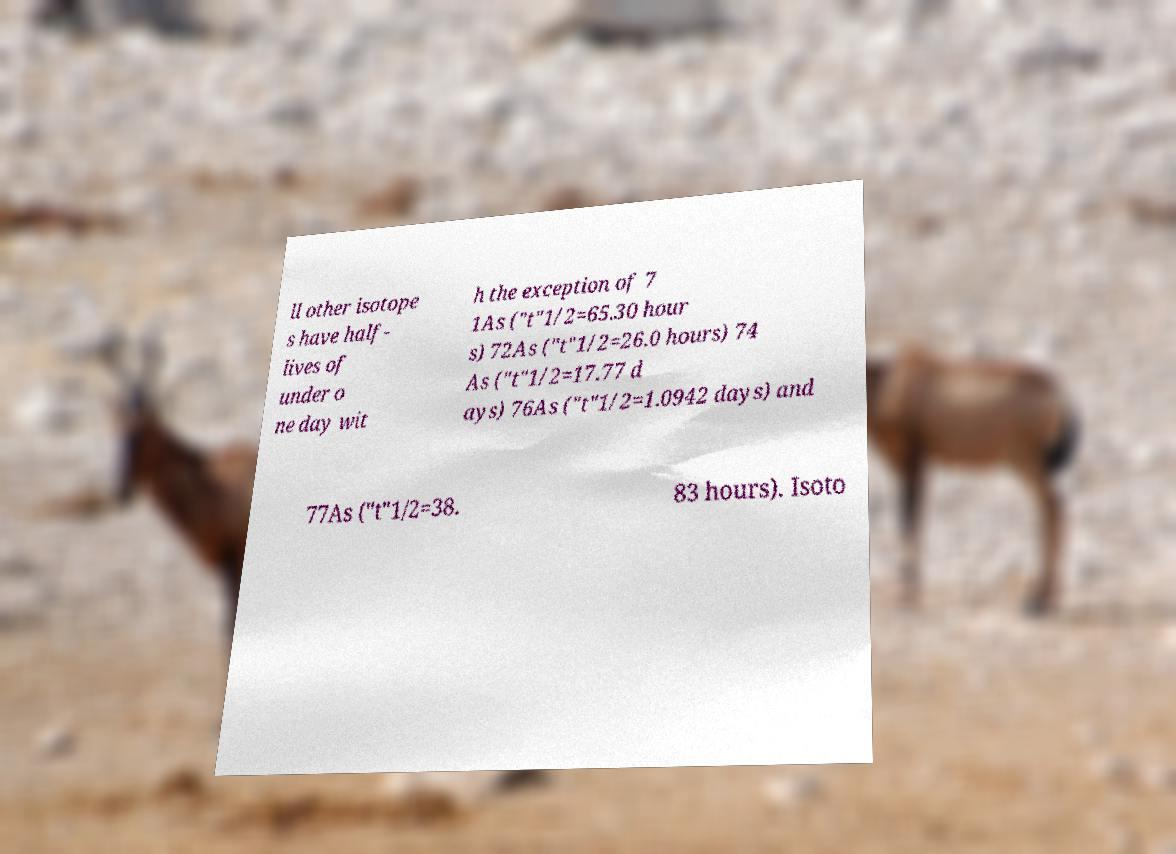Can you accurately transcribe the text from the provided image for me? ll other isotope s have half- lives of under o ne day wit h the exception of 7 1As ("t"1/2=65.30 hour s) 72As ("t"1/2=26.0 hours) 74 As ("t"1/2=17.77 d ays) 76As ("t"1/2=1.0942 days) and 77As ("t"1/2=38. 83 hours). Isoto 